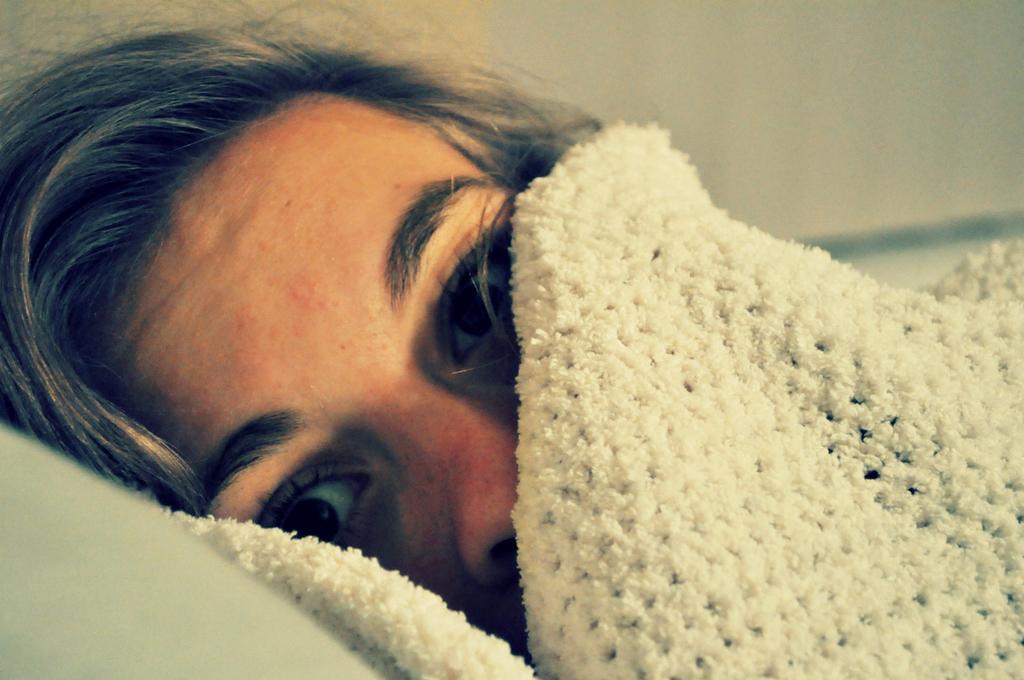Can you describe this image briefly? In this image, we can see there is a person lying, partially covered the face with a white color cloth and keeping head on a pillow. And the background is blurred. 